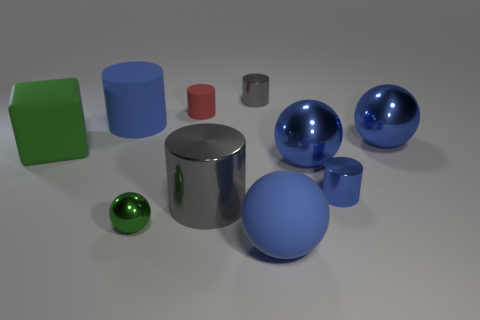There is a block that is the same color as the tiny ball; what material is it?
Provide a short and direct response. Rubber. Is there a metal ball that has the same color as the rubber block?
Give a very brief answer. Yes. Are there any large metallic cylinders to the left of the green shiny thing?
Your answer should be very brief. No. Is the material of the tiny cylinder on the left side of the tiny gray metallic cylinder the same as the blue cylinder behind the big cube?
Offer a terse response. Yes. What number of yellow matte balls are the same size as the rubber block?
Keep it short and to the point. 0. What is the shape of the big rubber object that is the same color as the rubber ball?
Your answer should be very brief. Cylinder. What is the object that is on the left side of the large blue matte cylinder made of?
Give a very brief answer. Rubber. How many other tiny matte things have the same shape as the tiny blue object?
Give a very brief answer. 1. The tiny red object that is the same material as the large blue cylinder is what shape?
Offer a very short reply. Cylinder. What shape is the blue object that is behind the thing that is on the right side of the blue cylinder that is in front of the blue rubber cylinder?
Offer a very short reply. Cylinder. 